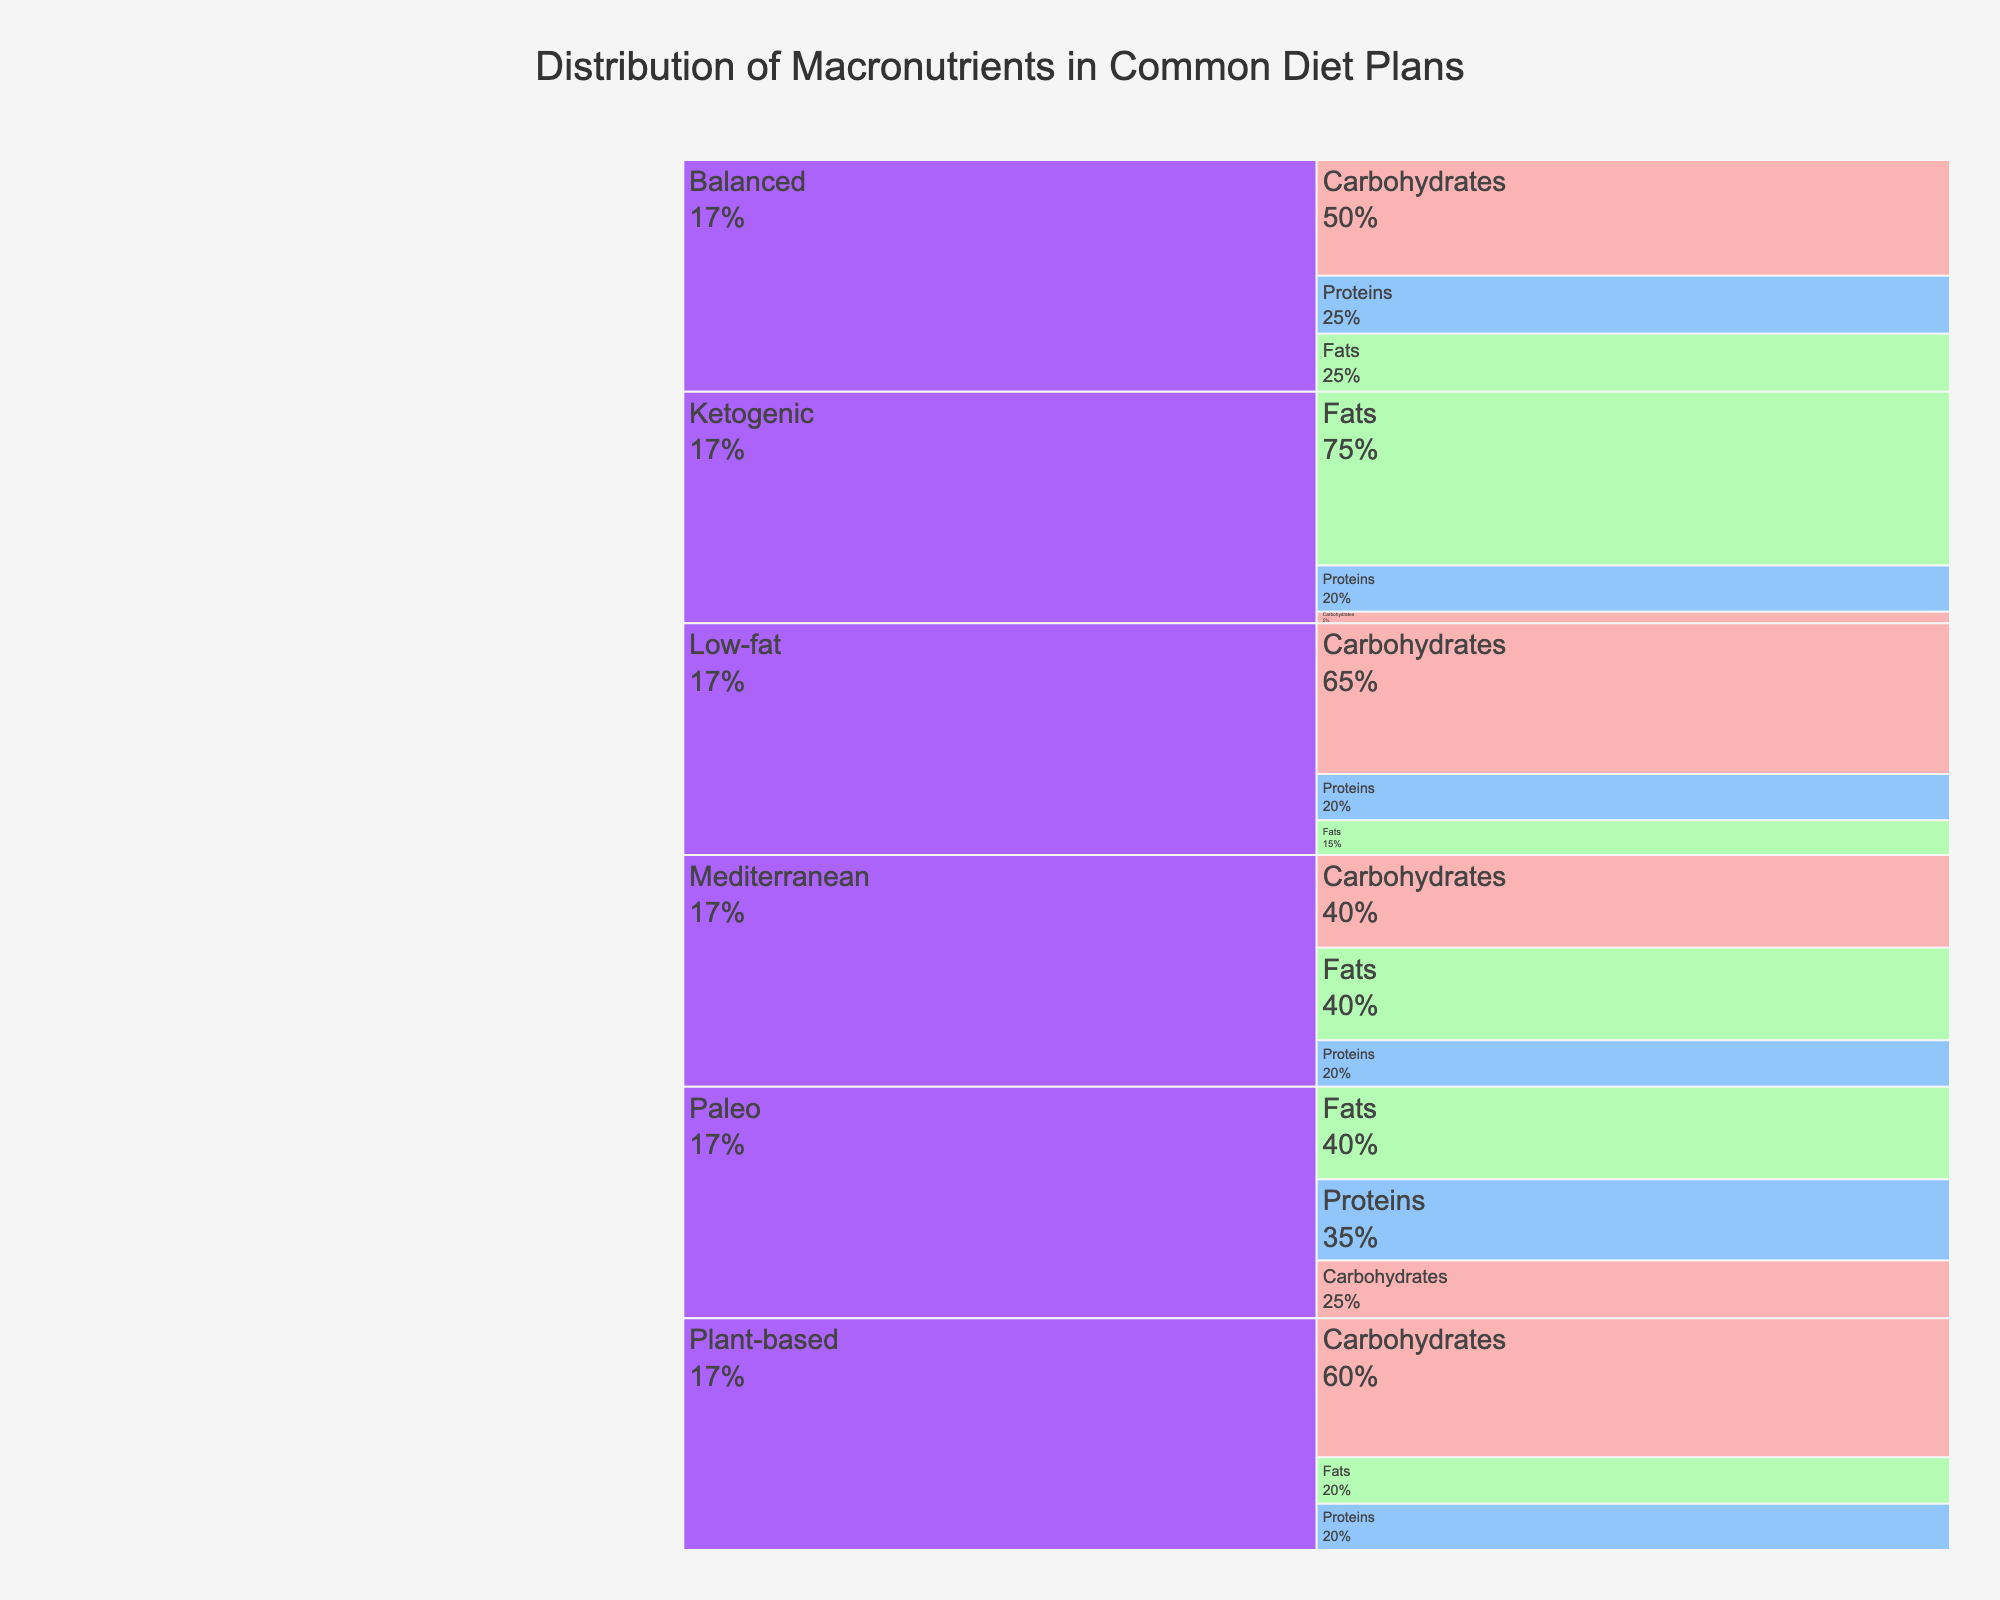What's the title of the figure? The title of the figure is located at the top center and is usually larger or differently formatted compared to the rest of the text in the figure. It provides an overview or main subject of what the figure represents.
Answer: Distribution of Macronutrients in Common Diet Plans How many diet plans are illustrated in the figure? By looking at the top level of the icicle chart, we can count the number of different categories or boxes that represent the diet plans.
Answer: 6 Which diet plan has the highest percentage of carbohydrates? From the icicle chart, we see the percentage values associated with carbohydrates for each diet plan. Identify the highest value.
Answer: Low-fat Compare the percentage of fats in the Mediterranean and the Paleo diet plans. Which one is higher? Find the percentages associated with fats for both the Mediterranean and the Paleo diet plans in the figure and compare them.
Answer: Same What is the total percentage of proteins in the Balanced and Plant-based diet plans combined? Locate the percentages of proteins for both the Balanced and Plant-based diet plans and add them together.
Answer: 45% Which macronutrient has the smallest overall percentage in the Ketogenic diet plan? Examine the percentages for carbohydrates, proteins, and fats under the Ketogenic diet plan and identify the smallest value.
Answer: Carbohydrates How does the percentage of fats in the Low-fat diet plan compare to the percentage of fats in the Paleo diet plan? Look at the percentages of fats in both the Low-fat and Paleo diet plans and compare them to see which is higher.
Answer: Low-fat has less What is the average percentage of proteins across all diet plans? Add up the percentage values for proteins from all diet plans and divide the total by the number of diet plans to get the average.
Answer: 23.3% In which diet plan do carbohydrates make up exactly 25% of the macronutrients? Locate the diet plan(s) where the carbohydrates percentage is exactly 25%.
Answer: Balanced By how much do the proteins in the Mediterranean diet plan exceed the fats in the Plant-based diet plan? Subtract the percentage of fats in the Plant-based diet plan from the percentage of proteins in the Mediterranean diet plan to find the difference.
Answer: 0% 